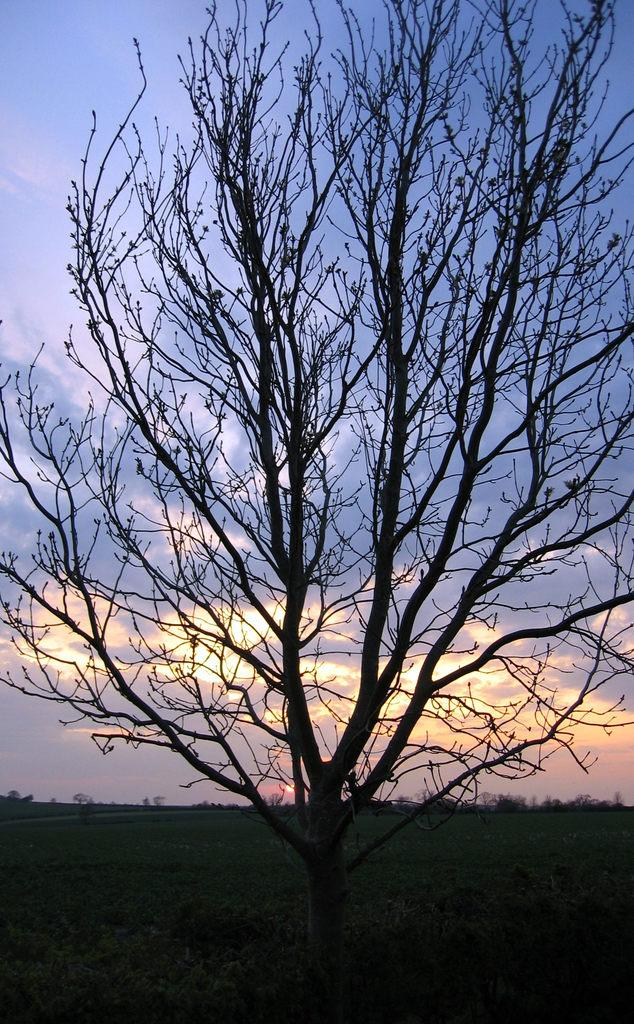What type of vegetation can be seen in the image? There are trees and plants in the image. What can be seen in the background of the image? The sky is visible in the background of the image. What is present in the sky? Clouds are present in the sky. What type of soap is hanging from the tree in the image? There is no soap present in the image; it features trees, plants, and a sky with clouds. How is the string used in the image? There is no string present in the image. What shape is the heart in the image? There is no heart present in the image. 